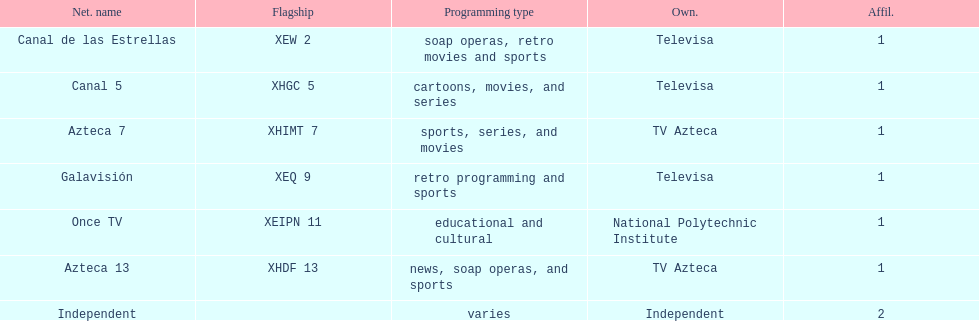Could you help me parse every detail presented in this table? {'header': ['Net. name', 'Flagship', 'Programming type', 'Own.', 'Affil.'], 'rows': [['Canal de las Estrellas', 'XEW 2', 'soap operas, retro movies and sports', 'Televisa', '1'], ['Canal 5', 'XHGC 5', 'cartoons, movies, and series', 'Televisa', '1'], ['Azteca 7', 'XHIMT 7', 'sports, series, and movies', 'TV Azteca', '1'], ['Galavisión', 'XEQ 9', 'retro programming and sports', 'Televisa', '1'], ['Once TV', 'XEIPN 11', 'educational and cultural', 'National Polytechnic Institute', '1'], ['Azteca 13', 'XHDF 13', 'news, soap operas, and sports', 'TV Azteca', '1'], ['Independent', '', 'varies', 'Independent', '2']]} How many networks do not air sports? 2. 